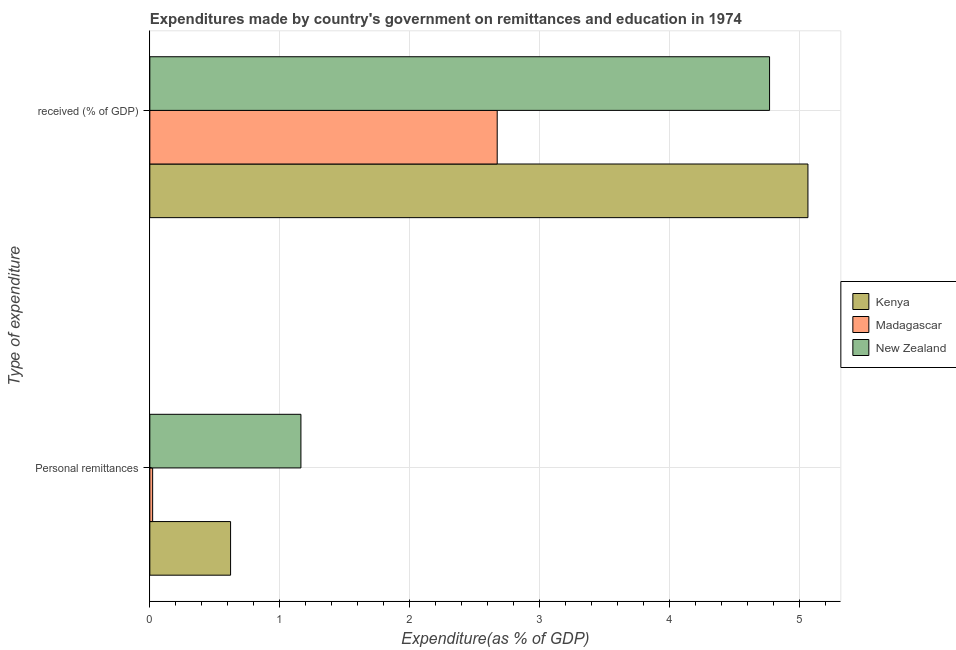How many groups of bars are there?
Ensure brevity in your answer.  2. How many bars are there on the 2nd tick from the top?
Make the answer very short. 3. How many bars are there on the 1st tick from the bottom?
Make the answer very short. 3. What is the label of the 1st group of bars from the top?
Offer a terse response.  received (% of GDP). What is the expenditure in personal remittances in New Zealand?
Offer a very short reply. 1.16. Across all countries, what is the maximum expenditure in education?
Give a very brief answer. 5.07. Across all countries, what is the minimum expenditure in education?
Provide a succinct answer. 2.67. In which country was the expenditure in personal remittances maximum?
Ensure brevity in your answer.  New Zealand. In which country was the expenditure in education minimum?
Your response must be concise. Madagascar. What is the total expenditure in education in the graph?
Make the answer very short. 12.51. What is the difference between the expenditure in personal remittances in Madagascar and that in Kenya?
Your answer should be very brief. -0.6. What is the difference between the expenditure in personal remittances in New Zealand and the expenditure in education in Madagascar?
Your answer should be compact. -1.51. What is the average expenditure in education per country?
Your answer should be very brief. 4.17. What is the difference between the expenditure in personal remittances and expenditure in education in Kenya?
Your answer should be compact. -4.44. What is the ratio of the expenditure in education in New Zealand to that in Kenya?
Ensure brevity in your answer.  0.94. Is the expenditure in personal remittances in New Zealand less than that in Madagascar?
Offer a very short reply. No. What does the 1st bar from the top in Personal remittances represents?
Your answer should be compact. New Zealand. What does the 1st bar from the bottom in  received (% of GDP) represents?
Provide a succinct answer. Kenya. How many bars are there?
Provide a succinct answer. 6. Are all the bars in the graph horizontal?
Provide a short and direct response. Yes. What is the difference between two consecutive major ticks on the X-axis?
Your response must be concise. 1. Are the values on the major ticks of X-axis written in scientific E-notation?
Your response must be concise. No. Does the graph contain grids?
Provide a succinct answer. Yes. How many legend labels are there?
Keep it short and to the point. 3. What is the title of the graph?
Provide a short and direct response. Expenditures made by country's government on remittances and education in 1974. What is the label or title of the X-axis?
Ensure brevity in your answer.  Expenditure(as % of GDP). What is the label or title of the Y-axis?
Provide a short and direct response. Type of expenditure. What is the Expenditure(as % of GDP) in Kenya in Personal remittances?
Give a very brief answer. 0.62. What is the Expenditure(as % of GDP) in Madagascar in Personal remittances?
Give a very brief answer. 0.02. What is the Expenditure(as % of GDP) of New Zealand in Personal remittances?
Provide a short and direct response. 1.16. What is the Expenditure(as % of GDP) of Kenya in  received (% of GDP)?
Your answer should be compact. 5.07. What is the Expenditure(as % of GDP) of Madagascar in  received (% of GDP)?
Keep it short and to the point. 2.67. What is the Expenditure(as % of GDP) in New Zealand in  received (% of GDP)?
Keep it short and to the point. 4.77. Across all Type of expenditure, what is the maximum Expenditure(as % of GDP) in Kenya?
Your response must be concise. 5.07. Across all Type of expenditure, what is the maximum Expenditure(as % of GDP) in Madagascar?
Make the answer very short. 2.67. Across all Type of expenditure, what is the maximum Expenditure(as % of GDP) in New Zealand?
Offer a terse response. 4.77. Across all Type of expenditure, what is the minimum Expenditure(as % of GDP) of Kenya?
Make the answer very short. 0.62. Across all Type of expenditure, what is the minimum Expenditure(as % of GDP) of Madagascar?
Provide a short and direct response. 0.02. Across all Type of expenditure, what is the minimum Expenditure(as % of GDP) in New Zealand?
Give a very brief answer. 1.16. What is the total Expenditure(as % of GDP) of Kenya in the graph?
Ensure brevity in your answer.  5.69. What is the total Expenditure(as % of GDP) in Madagascar in the graph?
Give a very brief answer. 2.7. What is the total Expenditure(as % of GDP) in New Zealand in the graph?
Ensure brevity in your answer.  5.93. What is the difference between the Expenditure(as % of GDP) of Kenya in Personal remittances and that in  received (% of GDP)?
Keep it short and to the point. -4.44. What is the difference between the Expenditure(as % of GDP) of Madagascar in Personal remittances and that in  received (% of GDP)?
Provide a succinct answer. -2.65. What is the difference between the Expenditure(as % of GDP) of New Zealand in Personal remittances and that in  received (% of GDP)?
Give a very brief answer. -3.61. What is the difference between the Expenditure(as % of GDP) of Kenya in Personal remittances and the Expenditure(as % of GDP) of Madagascar in  received (% of GDP)?
Give a very brief answer. -2.05. What is the difference between the Expenditure(as % of GDP) in Kenya in Personal remittances and the Expenditure(as % of GDP) in New Zealand in  received (% of GDP)?
Provide a short and direct response. -4.15. What is the difference between the Expenditure(as % of GDP) in Madagascar in Personal remittances and the Expenditure(as % of GDP) in New Zealand in  received (% of GDP)?
Offer a terse response. -4.75. What is the average Expenditure(as % of GDP) of Kenya per Type of expenditure?
Keep it short and to the point. 2.84. What is the average Expenditure(as % of GDP) in Madagascar per Type of expenditure?
Ensure brevity in your answer.  1.35. What is the average Expenditure(as % of GDP) of New Zealand per Type of expenditure?
Provide a succinct answer. 2.97. What is the difference between the Expenditure(as % of GDP) of Kenya and Expenditure(as % of GDP) of Madagascar in Personal remittances?
Provide a succinct answer. 0.6. What is the difference between the Expenditure(as % of GDP) in Kenya and Expenditure(as % of GDP) in New Zealand in Personal remittances?
Give a very brief answer. -0.54. What is the difference between the Expenditure(as % of GDP) of Madagascar and Expenditure(as % of GDP) of New Zealand in Personal remittances?
Keep it short and to the point. -1.14. What is the difference between the Expenditure(as % of GDP) in Kenya and Expenditure(as % of GDP) in Madagascar in  received (% of GDP)?
Your answer should be very brief. 2.39. What is the difference between the Expenditure(as % of GDP) in Kenya and Expenditure(as % of GDP) in New Zealand in  received (% of GDP)?
Your answer should be very brief. 0.3. What is the difference between the Expenditure(as % of GDP) in Madagascar and Expenditure(as % of GDP) in New Zealand in  received (% of GDP)?
Provide a succinct answer. -2.1. What is the ratio of the Expenditure(as % of GDP) of Kenya in Personal remittances to that in  received (% of GDP)?
Your answer should be very brief. 0.12. What is the ratio of the Expenditure(as % of GDP) of Madagascar in Personal remittances to that in  received (% of GDP)?
Offer a terse response. 0.01. What is the ratio of the Expenditure(as % of GDP) of New Zealand in Personal remittances to that in  received (% of GDP)?
Offer a very short reply. 0.24. What is the difference between the highest and the second highest Expenditure(as % of GDP) of Kenya?
Offer a very short reply. 4.44. What is the difference between the highest and the second highest Expenditure(as % of GDP) in Madagascar?
Provide a succinct answer. 2.65. What is the difference between the highest and the second highest Expenditure(as % of GDP) of New Zealand?
Provide a succinct answer. 3.61. What is the difference between the highest and the lowest Expenditure(as % of GDP) of Kenya?
Provide a short and direct response. 4.44. What is the difference between the highest and the lowest Expenditure(as % of GDP) in Madagascar?
Provide a short and direct response. 2.65. What is the difference between the highest and the lowest Expenditure(as % of GDP) of New Zealand?
Offer a terse response. 3.61. 